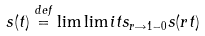Convert formula to latex. <formula><loc_0><loc_0><loc_500><loc_500>s ( t ) \stackrel { d e f } { = } \lim \lim i t s _ { r \rightarrow 1 - 0 } s ( r t )</formula> 